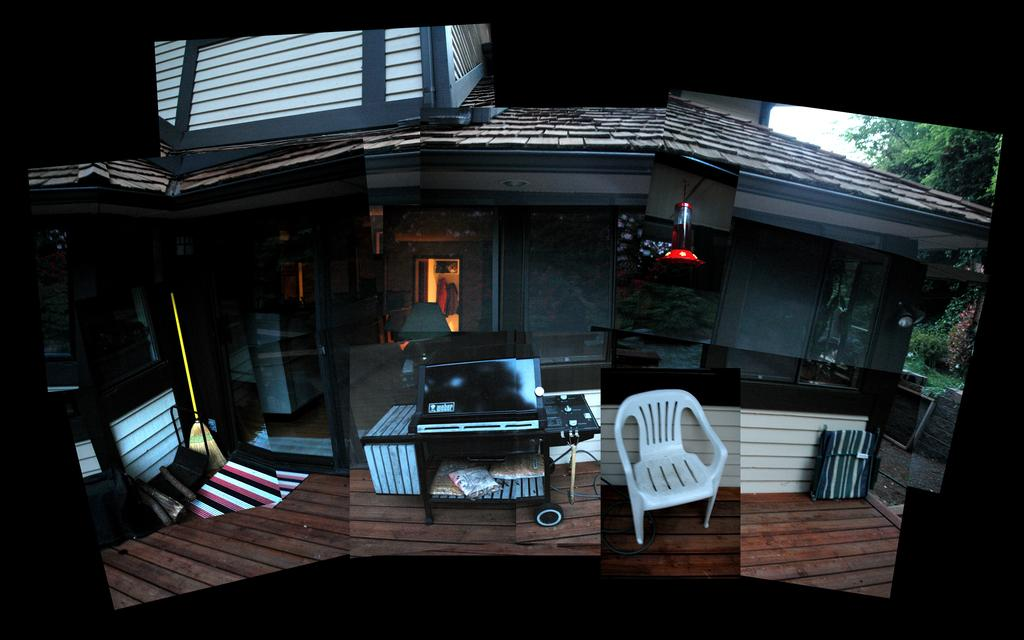What type of structure is visible in the image? There is a house in the image. What piece of furniture can be seen in the image? There is a chair in the image. What is the source of illumination in the image? There is light in the image. What type of vegetation is near the house in the image? There are trees beside the house in the image. Can you tell me how many horses are grazing in the front yard of the house in the image? There are no horses present in the image; it only shows a house, a chair, light, and trees. What type of beef is being served at the table in the image? There is no table or beef present in the image. 